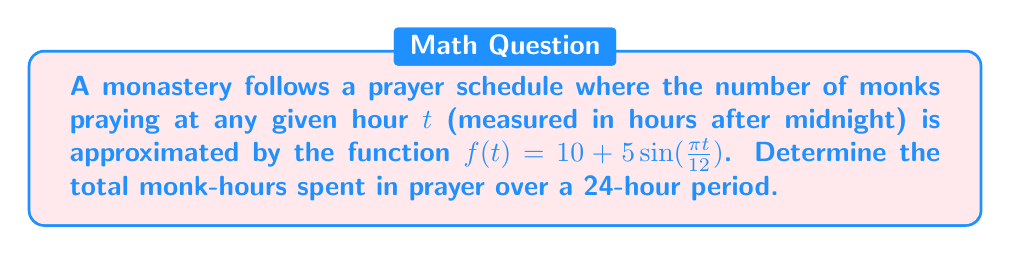Can you solve this math problem? To solve this problem, we need to calculate the area under the curve of $f(t)$ from $t=0$ to $t=24$. This can be done using a definite integral.

Step 1: Set up the integral
$$\int_0^{24} f(t) dt = \int_0^{24} (10 + 5\sin(\frac{\pi t}{12})) dt$$

Step 2: Integrate the function
$$\int_0^{24} 10 dt + \int_0^{24} 5\sin(\frac{\pi t}{12}) dt$$

The first part is straightforward:
$$10t \Big|_0^{24} = 240$$

For the second part, we use the substitution $u = \frac{\pi t}{12}$, $du = \frac{\pi}{12} dt$, $dt = \frac{12}{\pi} du$:

$$5 \cdot \frac{12}{\pi} \int_0^{2\pi} \sin(u) du = \frac{60}{\pi} [-\cos(u)]_0^{2\pi} = \frac{60}{\pi} [(-\cos(2\pi)) - (-\cos(0))] = 0$$

Step 3: Sum the results
Total area = 240 + 0 = 240 monk-hours
Answer: 240 monk-hours 